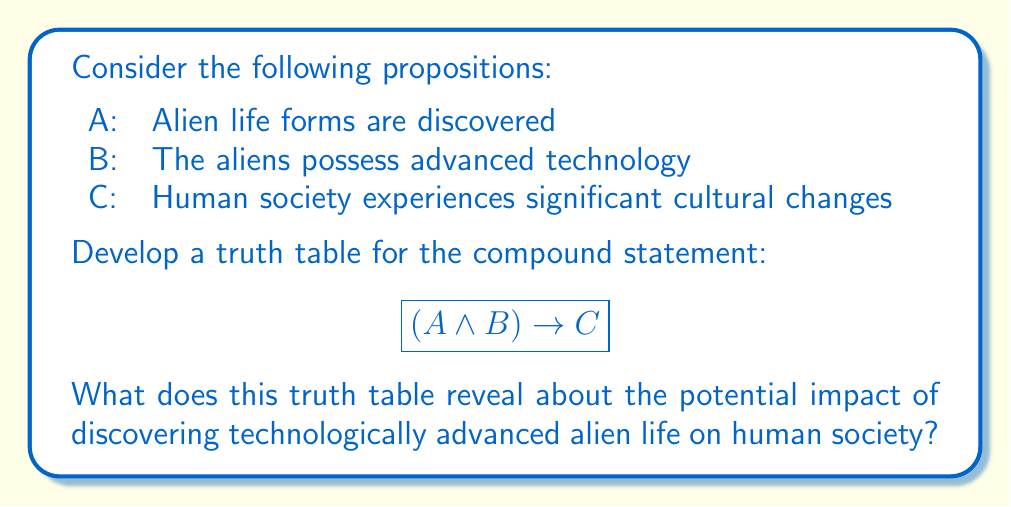Show me your answer to this math problem. To develop the truth table, we need to follow these steps:

1. Identify the number of rows: With 3 variables (A, B, C), we need $2^3 = 8$ rows.

2. List all possible combinations of truth values for A, B, and C:

   | A | B | C |
   |---|---|---|
   | T | T | T |
   | T | T | F |
   | T | F | T |
   | T | F | F |
   | F | T | T |
   | F | T | F |
   | F | F | T |
   | F | F | F |

3. Evaluate $A \land B$:

   | A | B | C | A ∧ B |
   |---|---|---|-------|
   | T | T | T |   T   |
   | T | T | F |   T   |
   | T | F | T |   F   |
   | T | F | F |   F   |
   | F | T | T |   F   |
   | F | T | F |   F   |
   | F | F | T |   F   |
   | F | F | F |   F   |

4. Evaluate $(A \land B) \rightarrow C$:

   | A | B | C | A ∧ B | (A ∧ B) → C |
   |---|---|---|-------|-------------|
   | T | T | T |   T   |      T      |
   | T | T | F |   T   |      F      |
   | T | F | T |   F   |      T      |
   | T | F | F |   F   |      T      |
   | F | T | T |   F   |      T      |
   | F | T | F |   F   |      T      |
   | F | F | T |   F   |      T      |
   | F | F | F |   F   |      T      |

5. Interpret the results:
   - The statement is false only when A and B are true, but C is false.
   - This means that if alien life is discovered (A) and they possess advanced technology (B), but human society does not experience significant cultural changes (not C), the implication is false.
   - In all other cases, including when alien life is not discovered or when they don't possess advanced technology, the implication holds true.

From a philosophical perspective, this truth table suggests that the discovery of technologically advanced alien life would likely lead to significant cultural changes in human society. The only scenario where this doesn't hold is when such a discovery occurs but inexplicably fails to impact human culture, which seems highly improbable given the potential magnitude of such a discovery.
Answer: The truth table reveals that significant cultural changes in human society are logically implied by the discovery of technologically advanced alien life, with only one improbable exception. 